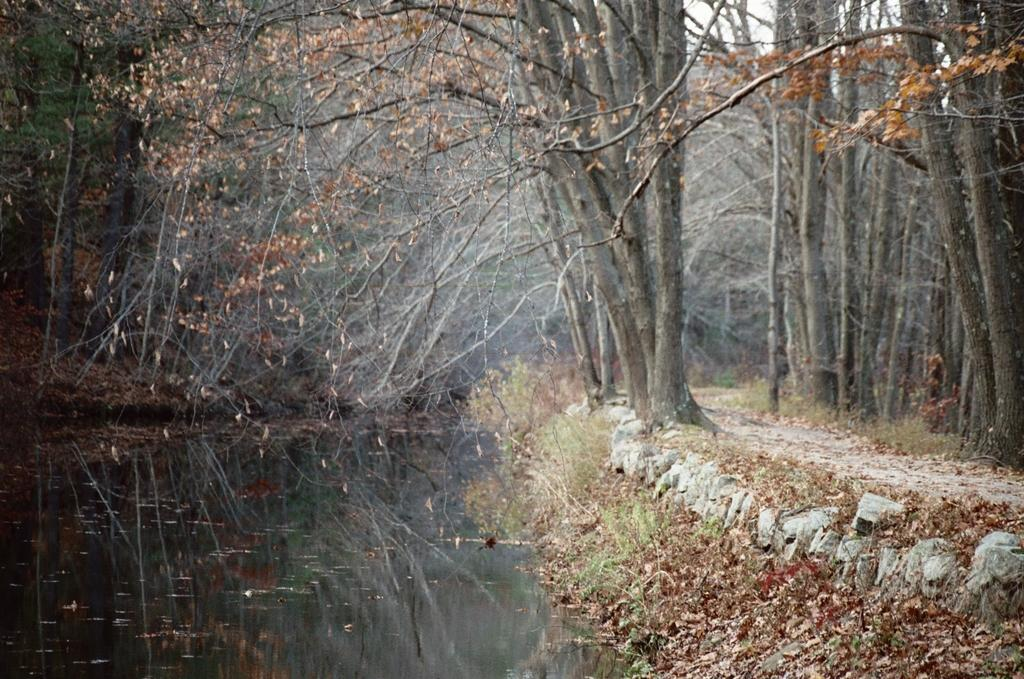What type of path is visible in the image? There is a walkway in the image. What natural elements can be seen along the walkway? There are rocks in the image. What body of water is located on the left side of the image? There is a pond on the left side of the image. What type of vegetation is present in the image? There are trees with dry leaves in the image. What is the condition of the sky in the image? The sky is clear in the image. What type of stamp is on the girl's forehead in the image? There is no girl or stamp present in the image. 